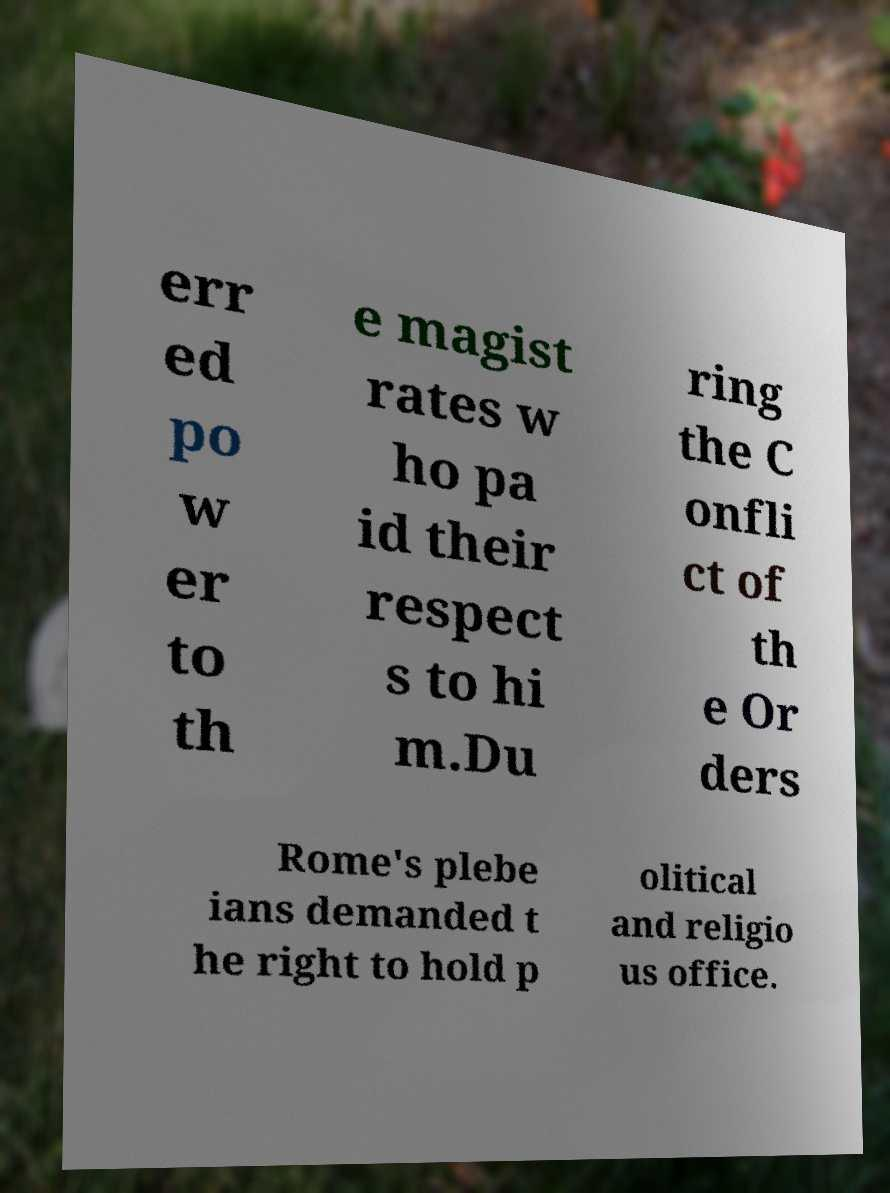I need the written content from this picture converted into text. Can you do that? err ed po w er to th e magist rates w ho pa id their respect s to hi m.Du ring the C onfli ct of th e Or ders Rome's plebe ians demanded t he right to hold p olitical and religio us office. 